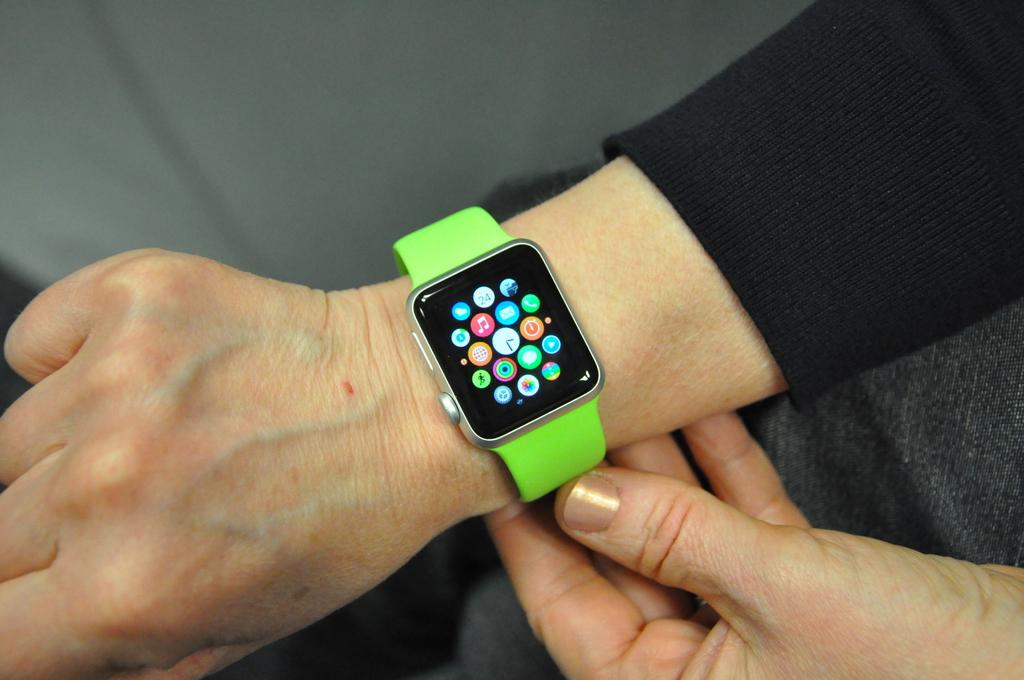Who or what is present in the image? There is a person in the image. What object can be seen on the person's wrist? There is a digital watch in the image. Can you determine the time of day when the image was taken? The image was likely taken during the day, as there is no indication of darkness or artificial lighting. What angle is the spy using to observe the person in the image? There is no indication of a spy or any spying activity in the image. The image simply shows a person with a digital watch. 